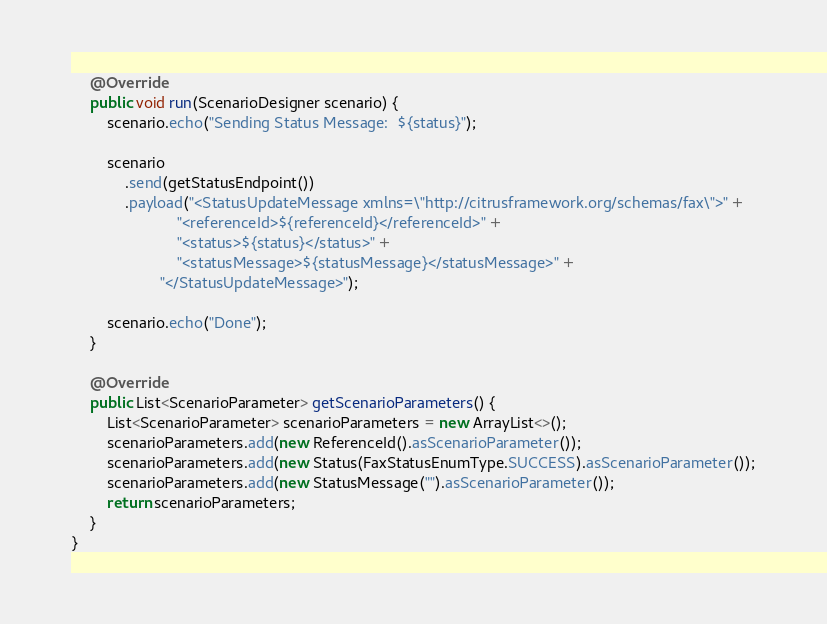<code> <loc_0><loc_0><loc_500><loc_500><_Java_>
    @Override
    public void run(ScenarioDesigner scenario) {
        scenario.echo("Sending Status Message:  ${status}");

        scenario
            .send(getStatusEndpoint())
            .payload("<StatusUpdateMessage xmlns=\"http://citrusframework.org/schemas/fax\">" +
                        "<referenceId>${referenceId}</referenceId>" +
                        "<status>${status}</status>" +
                        "<statusMessage>${statusMessage}</statusMessage>" +
                    "</StatusUpdateMessage>");

        scenario.echo("Done");
    }

    @Override
    public List<ScenarioParameter> getScenarioParameters() {
        List<ScenarioParameter> scenarioParameters = new ArrayList<>();
        scenarioParameters.add(new ReferenceId().asScenarioParameter());
        scenarioParameters.add(new Status(FaxStatusEnumType.SUCCESS).asScenarioParameter());
        scenarioParameters.add(new StatusMessage("").asScenarioParameter());
        return scenarioParameters;
    }
}
</code> 